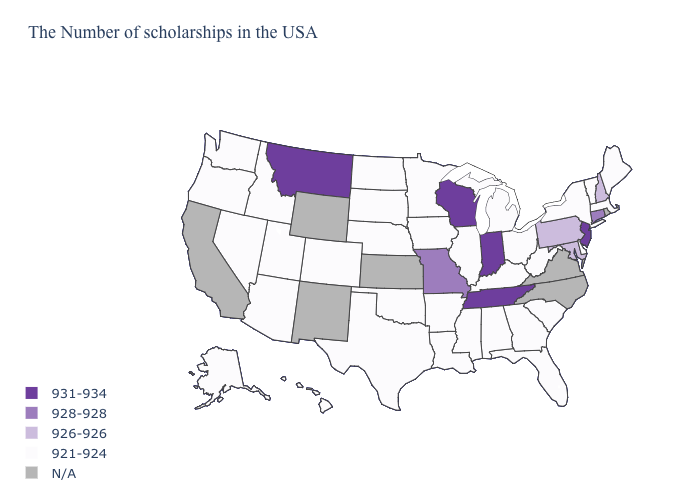What is the highest value in the USA?
Give a very brief answer. 931-934. Among the states that border Michigan , does Indiana have the highest value?
Short answer required. Yes. How many symbols are there in the legend?
Be succinct. 5. Does New Jersey have the highest value in the USA?
Write a very short answer. Yes. Among the states that border South Carolina , which have the lowest value?
Short answer required. Georgia. How many symbols are there in the legend?
Write a very short answer. 5. What is the value of Montana?
Concise answer only. 931-934. Name the states that have a value in the range 921-924?
Answer briefly. Maine, Massachusetts, Vermont, New York, Delaware, South Carolina, West Virginia, Ohio, Florida, Georgia, Michigan, Kentucky, Alabama, Illinois, Mississippi, Louisiana, Arkansas, Minnesota, Iowa, Nebraska, Oklahoma, Texas, South Dakota, North Dakota, Colorado, Utah, Arizona, Idaho, Nevada, Washington, Oregon, Alaska, Hawaii. Among the states that border Utah , which have the highest value?
Answer briefly. Colorado, Arizona, Idaho, Nevada. What is the value of West Virginia?
Write a very short answer. 921-924. Name the states that have a value in the range 926-926?
Write a very short answer. New Hampshire, Maryland, Pennsylvania. Name the states that have a value in the range 921-924?
Keep it brief. Maine, Massachusetts, Vermont, New York, Delaware, South Carolina, West Virginia, Ohio, Florida, Georgia, Michigan, Kentucky, Alabama, Illinois, Mississippi, Louisiana, Arkansas, Minnesota, Iowa, Nebraska, Oklahoma, Texas, South Dakota, North Dakota, Colorado, Utah, Arizona, Idaho, Nevada, Washington, Oregon, Alaska, Hawaii. Does Montana have the highest value in the USA?
Concise answer only. Yes. What is the value of Nevada?
Keep it brief. 921-924. Does Texas have the lowest value in the USA?
Write a very short answer. Yes. 